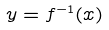Convert formula to latex. <formula><loc_0><loc_0><loc_500><loc_500>y = f ^ { - 1 } ( x )</formula> 